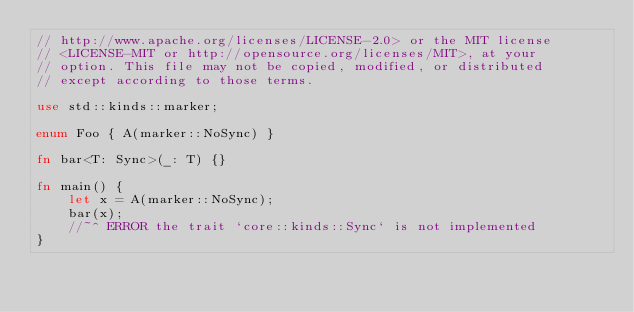Convert code to text. <code><loc_0><loc_0><loc_500><loc_500><_Rust_>// http://www.apache.org/licenses/LICENSE-2.0> or the MIT license
// <LICENSE-MIT or http://opensource.org/licenses/MIT>, at your
// option. This file may not be copied, modified, or distributed
// except according to those terms.

use std::kinds::marker;

enum Foo { A(marker::NoSync) }

fn bar<T: Sync>(_: T) {}

fn main() {
    let x = A(marker::NoSync);
    bar(x);
    //~^ ERROR the trait `core::kinds::Sync` is not implemented
}
</code> 